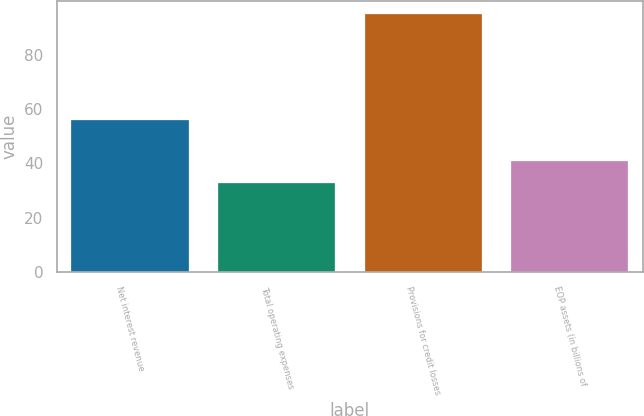<chart> <loc_0><loc_0><loc_500><loc_500><bar_chart><fcel>Net interest revenue<fcel>Total operating expenses<fcel>Provisions for credit losses<fcel>EOP assets (in billions of<nl><fcel>56<fcel>33<fcel>95<fcel>41<nl></chart> 